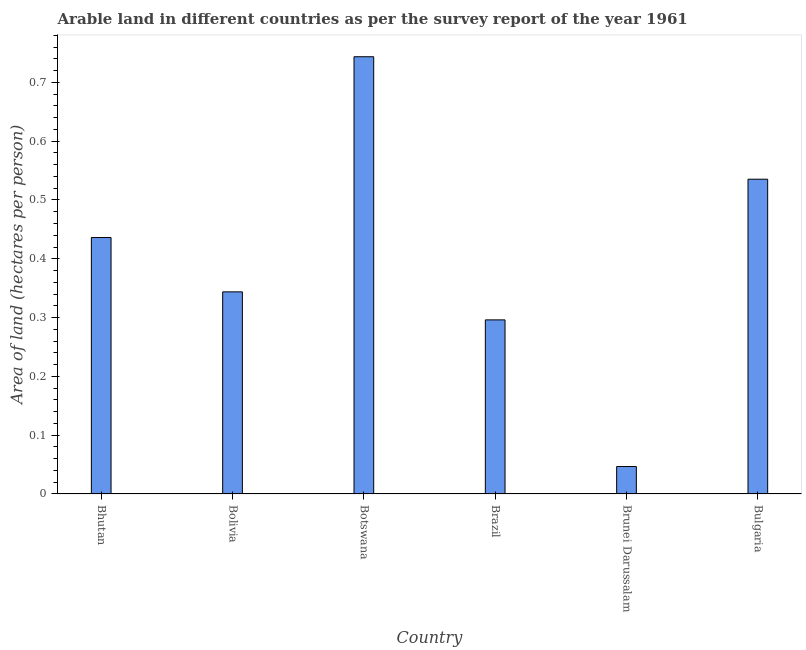Does the graph contain grids?
Ensure brevity in your answer.  No. What is the title of the graph?
Keep it short and to the point. Arable land in different countries as per the survey report of the year 1961. What is the label or title of the X-axis?
Give a very brief answer. Country. What is the label or title of the Y-axis?
Provide a short and direct response. Area of land (hectares per person). What is the area of arable land in Bulgaria?
Provide a succinct answer. 0.54. Across all countries, what is the maximum area of arable land?
Offer a terse response. 0.74. Across all countries, what is the minimum area of arable land?
Ensure brevity in your answer.  0.05. In which country was the area of arable land maximum?
Provide a short and direct response. Botswana. In which country was the area of arable land minimum?
Your response must be concise. Brunei Darussalam. What is the sum of the area of arable land?
Make the answer very short. 2.4. What is the difference between the area of arable land in Botswana and Brazil?
Your response must be concise. 0.45. What is the median area of arable land?
Offer a terse response. 0.39. What is the ratio of the area of arable land in Bhutan to that in Botswana?
Your answer should be compact. 0.59. Is the difference between the area of arable land in Brunei Darussalam and Bulgaria greater than the difference between any two countries?
Your answer should be compact. No. What is the difference between the highest and the second highest area of arable land?
Your response must be concise. 0.21. In how many countries, is the area of arable land greater than the average area of arable land taken over all countries?
Keep it short and to the point. 3. How many countries are there in the graph?
Keep it short and to the point. 6. What is the Area of land (hectares per person) of Bhutan?
Make the answer very short. 0.44. What is the Area of land (hectares per person) in Bolivia?
Your answer should be compact. 0.34. What is the Area of land (hectares per person) in Botswana?
Offer a very short reply. 0.74. What is the Area of land (hectares per person) in Brazil?
Your answer should be very brief. 0.3. What is the Area of land (hectares per person) in Brunei Darussalam?
Your answer should be compact. 0.05. What is the Area of land (hectares per person) of Bulgaria?
Your response must be concise. 0.54. What is the difference between the Area of land (hectares per person) in Bhutan and Bolivia?
Offer a terse response. 0.09. What is the difference between the Area of land (hectares per person) in Bhutan and Botswana?
Your answer should be very brief. -0.31. What is the difference between the Area of land (hectares per person) in Bhutan and Brazil?
Keep it short and to the point. 0.14. What is the difference between the Area of land (hectares per person) in Bhutan and Brunei Darussalam?
Offer a terse response. 0.39. What is the difference between the Area of land (hectares per person) in Bhutan and Bulgaria?
Your answer should be very brief. -0.1. What is the difference between the Area of land (hectares per person) in Bolivia and Botswana?
Provide a succinct answer. -0.4. What is the difference between the Area of land (hectares per person) in Bolivia and Brazil?
Ensure brevity in your answer.  0.05. What is the difference between the Area of land (hectares per person) in Bolivia and Brunei Darussalam?
Provide a succinct answer. 0.3. What is the difference between the Area of land (hectares per person) in Bolivia and Bulgaria?
Provide a short and direct response. -0.19. What is the difference between the Area of land (hectares per person) in Botswana and Brazil?
Your answer should be very brief. 0.45. What is the difference between the Area of land (hectares per person) in Botswana and Brunei Darussalam?
Your response must be concise. 0.7. What is the difference between the Area of land (hectares per person) in Botswana and Bulgaria?
Ensure brevity in your answer.  0.21. What is the difference between the Area of land (hectares per person) in Brazil and Brunei Darussalam?
Provide a succinct answer. 0.25. What is the difference between the Area of land (hectares per person) in Brazil and Bulgaria?
Your answer should be very brief. -0.24. What is the difference between the Area of land (hectares per person) in Brunei Darussalam and Bulgaria?
Provide a succinct answer. -0.49. What is the ratio of the Area of land (hectares per person) in Bhutan to that in Bolivia?
Your answer should be very brief. 1.27. What is the ratio of the Area of land (hectares per person) in Bhutan to that in Botswana?
Your response must be concise. 0.59. What is the ratio of the Area of land (hectares per person) in Bhutan to that in Brazil?
Ensure brevity in your answer.  1.47. What is the ratio of the Area of land (hectares per person) in Bhutan to that in Brunei Darussalam?
Offer a very short reply. 9.34. What is the ratio of the Area of land (hectares per person) in Bhutan to that in Bulgaria?
Offer a very short reply. 0.81. What is the ratio of the Area of land (hectares per person) in Bolivia to that in Botswana?
Give a very brief answer. 0.46. What is the ratio of the Area of land (hectares per person) in Bolivia to that in Brazil?
Your response must be concise. 1.16. What is the ratio of the Area of land (hectares per person) in Bolivia to that in Brunei Darussalam?
Offer a very short reply. 7.36. What is the ratio of the Area of land (hectares per person) in Bolivia to that in Bulgaria?
Offer a very short reply. 0.64. What is the ratio of the Area of land (hectares per person) in Botswana to that in Brazil?
Provide a short and direct response. 2.51. What is the ratio of the Area of land (hectares per person) in Botswana to that in Brunei Darussalam?
Your answer should be compact. 15.93. What is the ratio of the Area of land (hectares per person) in Botswana to that in Bulgaria?
Make the answer very short. 1.39. What is the ratio of the Area of land (hectares per person) in Brazil to that in Brunei Darussalam?
Give a very brief answer. 6.34. What is the ratio of the Area of land (hectares per person) in Brazil to that in Bulgaria?
Your response must be concise. 0.55. What is the ratio of the Area of land (hectares per person) in Brunei Darussalam to that in Bulgaria?
Ensure brevity in your answer.  0.09. 